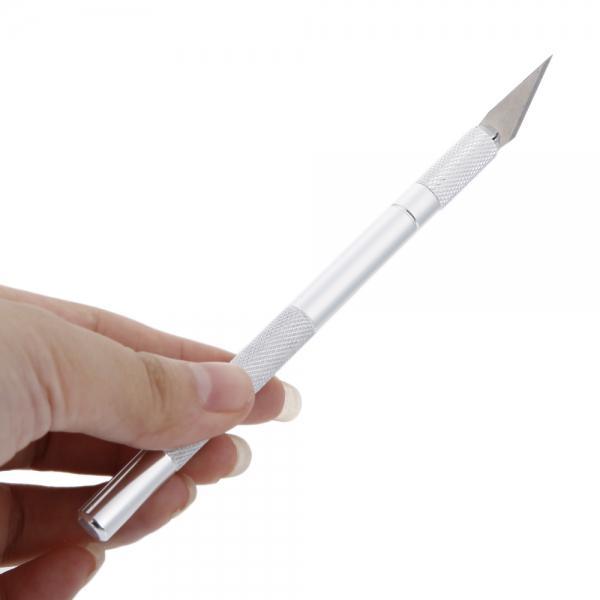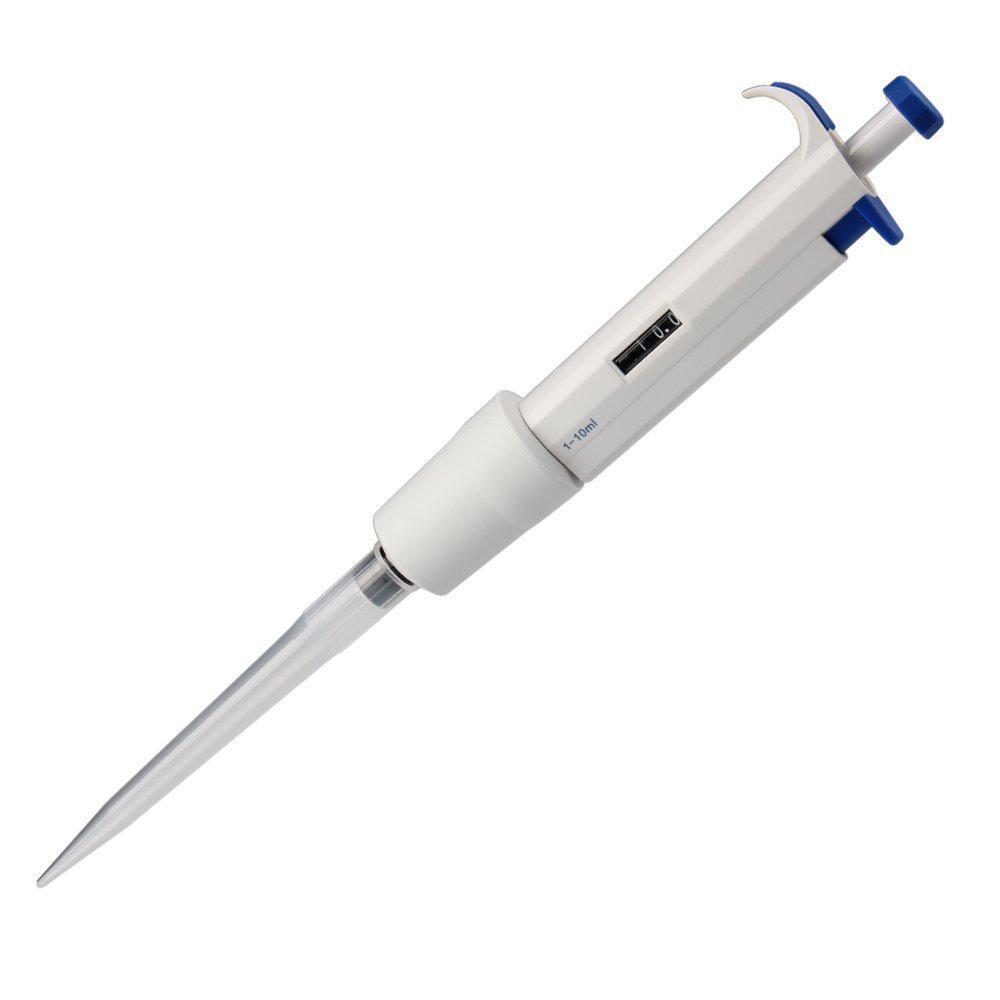The first image is the image on the left, the second image is the image on the right. Assess this claim about the two images: "there at least one syringe in the image on the left". Correct or not? Answer yes or no. No. The first image is the image on the left, the second image is the image on the right. Assess this claim about the two images: "One is pointing up to the right, and the other down to the left.". Correct or not? Answer yes or no. Yes. 